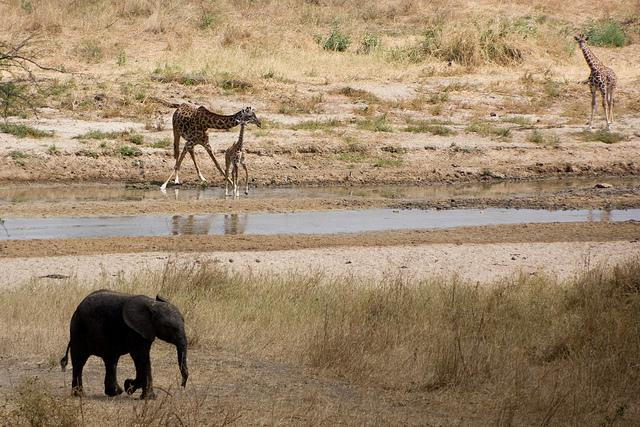Why does that animal have its legs spread?

Choices:
A) to drink
B) to sleep
C) to hide
D) to swim to drink 